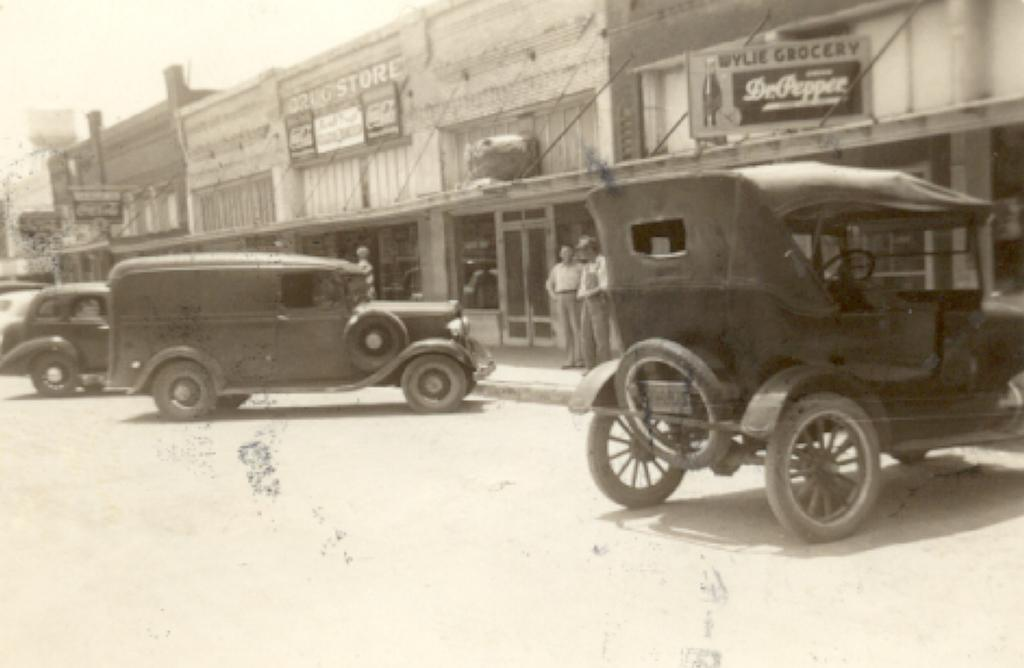What is the color scheme of the image? The image is black and white. What types of objects can be seen in the image? There are vehicles and buildings in the image. What other items are present in the image? There are boards in the image. How many people are in the image? There are two persons in the image. What is visible in the background of the image? The sky is visible in the background of the image. What type of body is visible in the image? There is no body present in the image; it features vehicles, buildings, boards, and two persons. What color is the paint used on the vehicles in the image? The image is black and white, so it is not possible to determine the color of the paint used on the vehicles. 